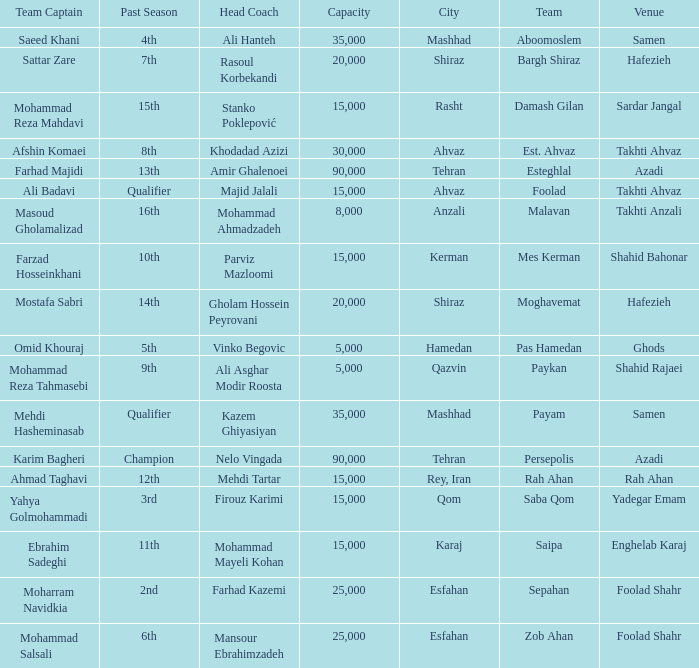What Venue has a Past Season of 2nd? Foolad Shahr. Can you parse all the data within this table? {'header': ['Team Captain', 'Past Season', 'Head Coach', 'Capacity', 'City', 'Team', 'Venue'], 'rows': [['Saeed Khani', '4th', 'Ali Hanteh', '35,000', 'Mashhad', 'Aboomoslem', 'Samen'], ['Sattar Zare', '7th', 'Rasoul Korbekandi', '20,000', 'Shiraz', 'Bargh Shiraz', 'Hafezieh'], ['Mohammad Reza Mahdavi', '15th', 'Stanko Poklepović', '15,000', 'Rasht', 'Damash Gilan', 'Sardar Jangal'], ['Afshin Komaei', '8th', 'Khodadad Azizi', '30,000', 'Ahvaz', 'Est. Ahvaz', 'Takhti Ahvaz'], ['Farhad Majidi', '13th', 'Amir Ghalenoei', '90,000', 'Tehran', 'Esteghlal', 'Azadi'], ['Ali Badavi', 'Qualifier', 'Majid Jalali', '15,000', 'Ahvaz', 'Foolad', 'Takhti Ahvaz'], ['Masoud Gholamalizad', '16th', 'Mohammad Ahmadzadeh', '8,000', 'Anzali', 'Malavan', 'Takhti Anzali'], ['Farzad Hosseinkhani', '10th', 'Parviz Mazloomi', '15,000', 'Kerman', 'Mes Kerman', 'Shahid Bahonar'], ['Mostafa Sabri', '14th', 'Gholam Hossein Peyrovani', '20,000', 'Shiraz', 'Moghavemat', 'Hafezieh'], ['Omid Khouraj', '5th', 'Vinko Begovic', '5,000', 'Hamedan', 'Pas Hamedan', 'Ghods'], ['Mohammad Reza Tahmasebi', '9th', 'Ali Asghar Modir Roosta', '5,000', 'Qazvin', 'Paykan', 'Shahid Rajaei'], ['Mehdi Hasheminasab', 'Qualifier', 'Kazem Ghiyasiyan', '35,000', 'Mashhad', 'Payam', 'Samen'], ['Karim Bagheri', 'Champion', 'Nelo Vingada', '90,000', 'Tehran', 'Persepolis', 'Azadi'], ['Ahmad Taghavi', '12th', 'Mehdi Tartar', '15,000', 'Rey, Iran', 'Rah Ahan', 'Rah Ahan'], ['Yahya Golmohammadi', '3rd', 'Firouz Karimi', '15,000', 'Qom', 'Saba Qom', 'Yadegar Emam'], ['Ebrahim Sadeghi', '11th', 'Mohammad Mayeli Kohan', '15,000', 'Karaj', 'Saipa', 'Enghelab Karaj'], ['Moharram Navidkia', '2nd', 'Farhad Kazemi', '25,000', 'Esfahan', 'Sepahan', 'Foolad Shahr'], ['Mohammad Salsali', '6th', 'Mansour Ebrahimzadeh', '25,000', 'Esfahan', 'Zob Ahan', 'Foolad Shahr']]} 